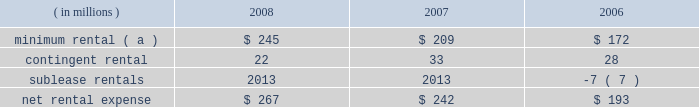Marathon oil corporation notes to consolidated financial statements operating lease rental expense was : ( in millions ) 2008 2007 2006 minimum rental ( a ) $ 245 $ 209 $ 172 .
( a ) excludes $ 5 million , $ 8 million and $ 9 million paid by united states steel in 2008 , 2007 and 2006 on assumed leases .
27 .
Contingencies and commitments we are the subject of , or party to , a number of pending or threatened legal actions , contingencies and commitments involving a variety of matters , including laws and regulations relating to the environment .
Certain of these matters are discussed below .
The ultimate resolution of these contingencies could , individually or in the aggregate , be material to our consolidated financial statements .
However , management believes that we will remain a viable and competitive enterprise even though it is possible that these contingencies could be resolved unfavorably .
Environmental matters 2013 we are subject to federal , state , local and foreign laws and regulations relating to the environment .
These laws generally provide for control of pollutants released into the environment and require responsible parties to undertake remediation of hazardous waste disposal sites .
Penalties may be imposed for noncompliance .
At december 31 , 2008 and 2007 , accrued liabilities for remediation totaled $ 111 million and $ 108 million .
It is not presently possible to estimate the ultimate amount of all remediation costs that might be incurred or the penalties that may be imposed .
Receivables for recoverable costs from certain states , under programs to assist companies in clean-up efforts related to underground storage tanks at retail marketing outlets , were $ 60 and $ 66 million at december 31 , 2008 and 2007 .
We are a defendant , along with other refining companies , in 20 cases arising in three states alleging damages for methyl tertiary-butyl ether ( 201cmtbe 201d ) contamination .
We have also received seven toxic substances control act notice letters involving potential claims in two states .
Such notice letters are often followed by litigation .
Like the cases that were settled in 2008 , the remaining mtbe cases are consolidated in a multidistrict litigation in the southern district of new york for pretrial proceedings .
Nineteen of the remaining cases allege damages to water supply wells , similar to the damages claimed in the settled cases .
In the other remaining case , the state of new jersey is seeking natural resources damages allegedly resulting from contamination of groundwater by mtbe .
This is the only mtbe contamination case in which we are a defendant and natural resources damages are sought .
We are vigorously defending these cases .
We , along with a number of other defendants , have engaged in settlement discussions related to the majority of the cases in which we are a defendant .
We do not expect our share of liability , if any , for the remaining cases to significantly impact our consolidated results of operations , financial position or cash flows .
A lawsuit filed in the united states district court for the southern district of west virginia alleges that our catlettsburg , kentucky , refinery distributed contaminated gasoline to wholesalers and retailers for a period prior to august , 2003 , causing permanent damage to storage tanks , dispensers and related equipment , resulting in lost profits , business disruption and personal and real property damages .
Following the incident , we conducted remediation operations at affected facilities , and we deny that any permanent damages resulted from the incident .
Class action certification was granted in august 2007 .
We have entered into a tentative settlement agreement in this case .
Notice of the proposed settlement has been sent to the class members .
Approval by the court after a fairness hearing is required before the settlement can be finalized .
The fairness hearing is scheduled in the first quarter of 2009 .
The proposed settlement will not significantly impact our consolidated results of operations , financial position or cash flows .
Guarantees 2013 we have provided certain guarantees , direct and indirect , of the indebtedness of other companies .
Under the terms of most of these guarantee arrangements , we would be required to perform should the guaranteed party fail to fulfill its obligations under the specified arrangements .
In addition to these financial guarantees , we also have various performance guarantees related to specific agreements. .
By how much did net rental expense increase from 2006 to 2008? 
Computations: ((267 - 193) / 193)
Answer: 0.38342. 